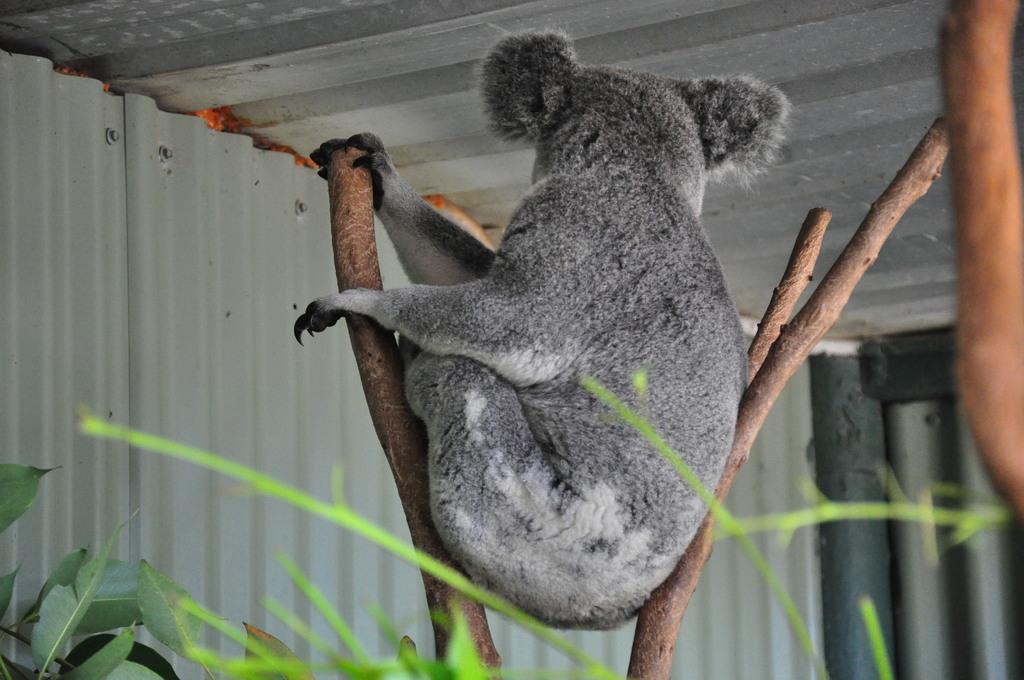How would you summarize this image in a sentence or two? In this image I can see an animal in between the sticks and the animal is in gray color, background I can see few plants in green color and I can also see the shed in gray color. 